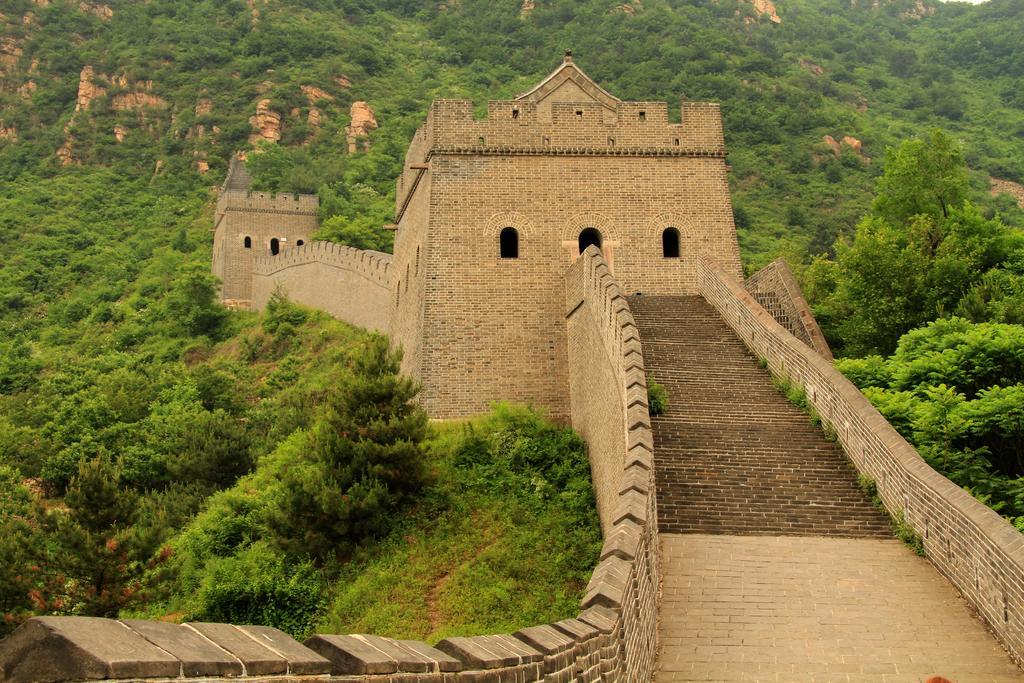Could you give a brief overview of what you see in this image? In this image we can see a monument and trees. 